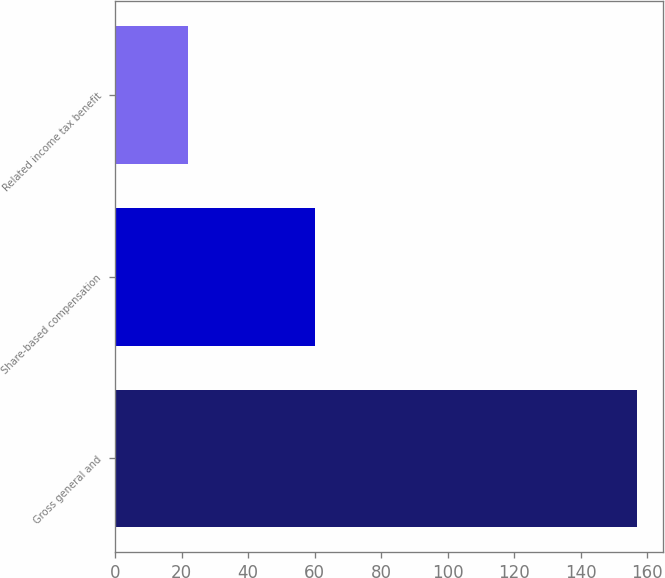Convert chart. <chart><loc_0><loc_0><loc_500><loc_500><bar_chart><fcel>Gross general and<fcel>Share-based compensation<fcel>Related income tax benefit<nl><fcel>157<fcel>60<fcel>22<nl></chart> 